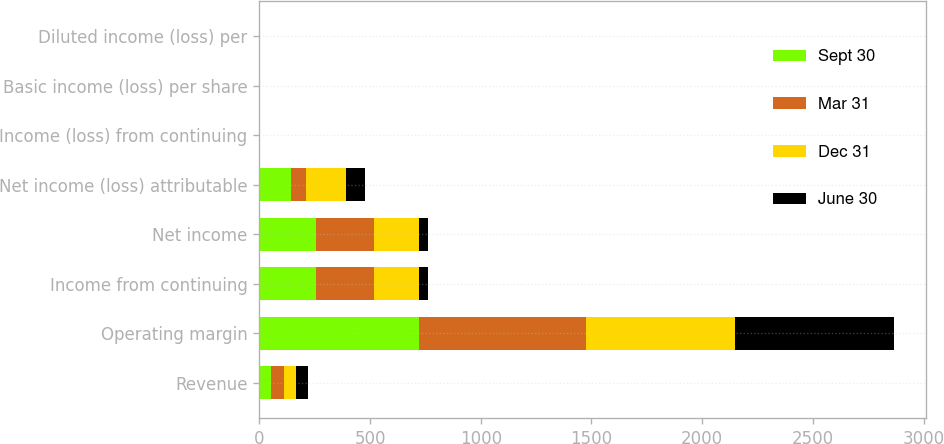<chart> <loc_0><loc_0><loc_500><loc_500><stacked_bar_chart><ecel><fcel>Revenue<fcel>Operating margin<fcel>Income from continuing<fcel>Net income<fcel>Net income (loss) attributable<fcel>Income (loss) from continuing<fcel>Basic income (loss) per share<fcel>Diluted income (loss) per<nl><fcel>Sept 30<fcel>55<fcel>721<fcel>254<fcel>254<fcel>142<fcel>0.2<fcel>0.2<fcel>0.2<nl><fcel>Mar 31<fcel>55<fcel>754<fcel>264<fcel>264<fcel>69<fcel>0.1<fcel>0.1<fcel>0.1<nl><fcel>Dec 31<fcel>55<fcel>673<fcel>203<fcel>203<fcel>180<fcel>0.27<fcel>0.27<fcel>0.26<nl><fcel>June 30<fcel>55<fcel>718<fcel>41<fcel>41<fcel>85<fcel>0.13<fcel>0.13<fcel>0.13<nl></chart> 